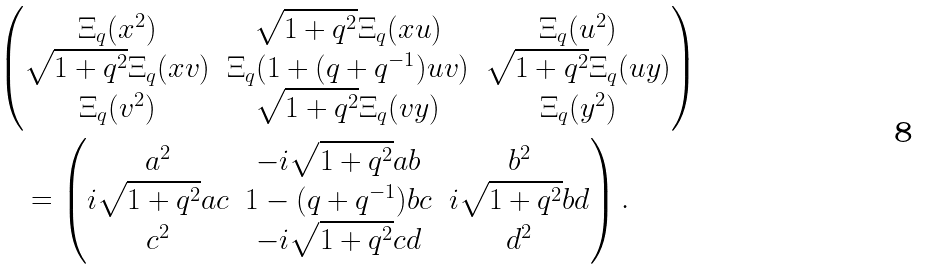<formula> <loc_0><loc_0><loc_500><loc_500>& \begin{pmatrix} \Xi _ { q } ( x ^ { 2 } ) & \sqrt { 1 + q ^ { 2 } } \Xi _ { q } ( x u ) & \Xi _ { q } ( u ^ { 2 } ) \\ \sqrt { 1 + q ^ { 2 } } \Xi _ { q } ( x v ) & \Xi _ { q } ( 1 + ( q + q ^ { - 1 } ) u v ) & \sqrt { 1 + q ^ { 2 } } \Xi _ { q } ( u y ) \\ \Xi _ { q } ( v ^ { 2 } ) & \sqrt { 1 + q ^ { 2 } } \Xi _ { q } ( v y ) & \Xi _ { q } ( y ^ { 2 } ) \end{pmatrix} \\ & \quad = \begin{pmatrix} a ^ { 2 } & - i \sqrt { 1 + q ^ { 2 } } a b & b ^ { 2 } \\ i \sqrt { 1 + q ^ { 2 } } a c & 1 - ( q + q ^ { - 1 } ) b c & i \sqrt { 1 + q ^ { 2 } } b d \\ c ^ { 2 } & - i \sqrt { 1 + q ^ { 2 } } c d & d ^ { 2 } \end{pmatrix} .</formula> 